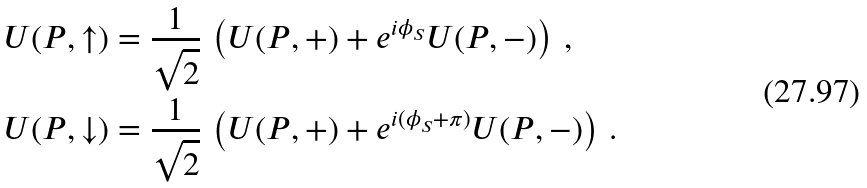<formula> <loc_0><loc_0><loc_500><loc_500>U ( P , \uparrow ) & = \frac { 1 } { \sqrt { 2 } } \, \left ( U ( P , + ) + e ^ { i \phi _ { S } } U ( P , - ) \right ) \, , \\ U ( P , \downarrow ) & = \frac { 1 } { \sqrt { 2 } } \, \left ( U ( P , + ) + e ^ { i ( \phi _ { S } + \pi ) } U ( P , - ) \right ) \, .</formula> 